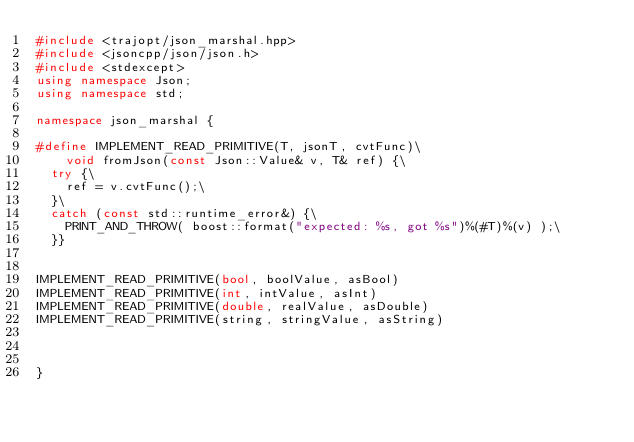Convert code to text. <code><loc_0><loc_0><loc_500><loc_500><_C++_>#include <trajopt/json_marshal.hpp>
#include <jsoncpp/json/json.h>
#include <stdexcept>
using namespace Json;
using namespace std;

namespace json_marshal {

#define IMPLEMENT_READ_PRIMITIVE(T, jsonT, cvtFunc)\
    void fromJson(const Json::Value& v, T& ref) {\
  try {\
    ref = v.cvtFunc();\
  }\
  catch (const std::runtime_error&) {\
    PRINT_AND_THROW( boost::format("expected: %s, got %s")%(#T)%(v) );\
  }}


IMPLEMENT_READ_PRIMITIVE(bool, boolValue, asBool)
IMPLEMENT_READ_PRIMITIVE(int, intValue, asInt)
IMPLEMENT_READ_PRIMITIVE(double, realValue, asDouble)
IMPLEMENT_READ_PRIMITIVE(string, stringValue, asString)



}
</code> 